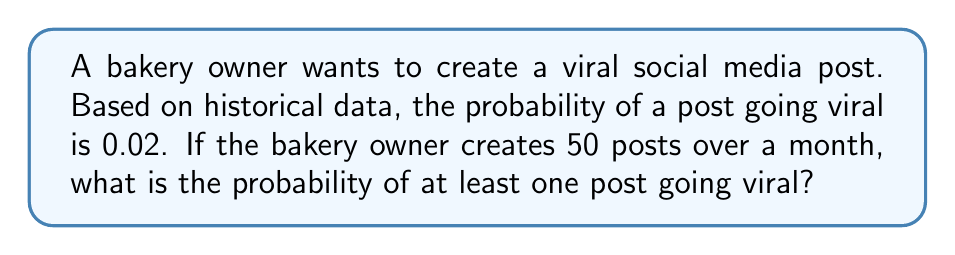Provide a solution to this math problem. To solve this problem, we can use the concept of complementary events in probability theory.

Let's define the following events:
- A: At least one post goes viral
- B: No posts go viral

We want to find P(A), but it's easier to calculate P(B) first and then use the fact that P(A) = 1 - P(B).

To calculate P(B):
1. The probability of a single post not going viral is 1 - 0.02 = 0.98
2. For all 50 posts to not go viral, this must happen independently 50 times
3. Therefore, P(B) = $(0.98)^{50}$

Now we can calculate P(A):

$$\begin{align}
P(A) &= 1 - P(B) \\
&= 1 - (0.98)^{50} \\
&\approx 1 - 0.3641 \\
&\approx 0.6359
\end{align}$$

This can be expressed as a percentage: 63.59%
Answer: The probability of at least one post going viral is approximately 0.6359 or 63.59%. 